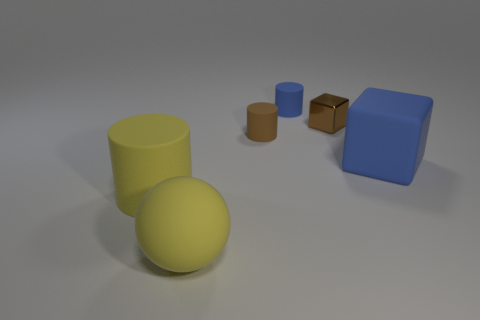Subtract 1 cylinders. How many cylinders are left? 2 Add 3 yellow rubber spheres. How many objects exist? 9 Subtract all spheres. How many objects are left? 5 Add 3 brown objects. How many brown objects are left? 5 Add 1 red rubber objects. How many red rubber objects exist? 1 Subtract 0 red cubes. How many objects are left? 6 Subtract all large cyan metal spheres. Subtract all small blocks. How many objects are left? 5 